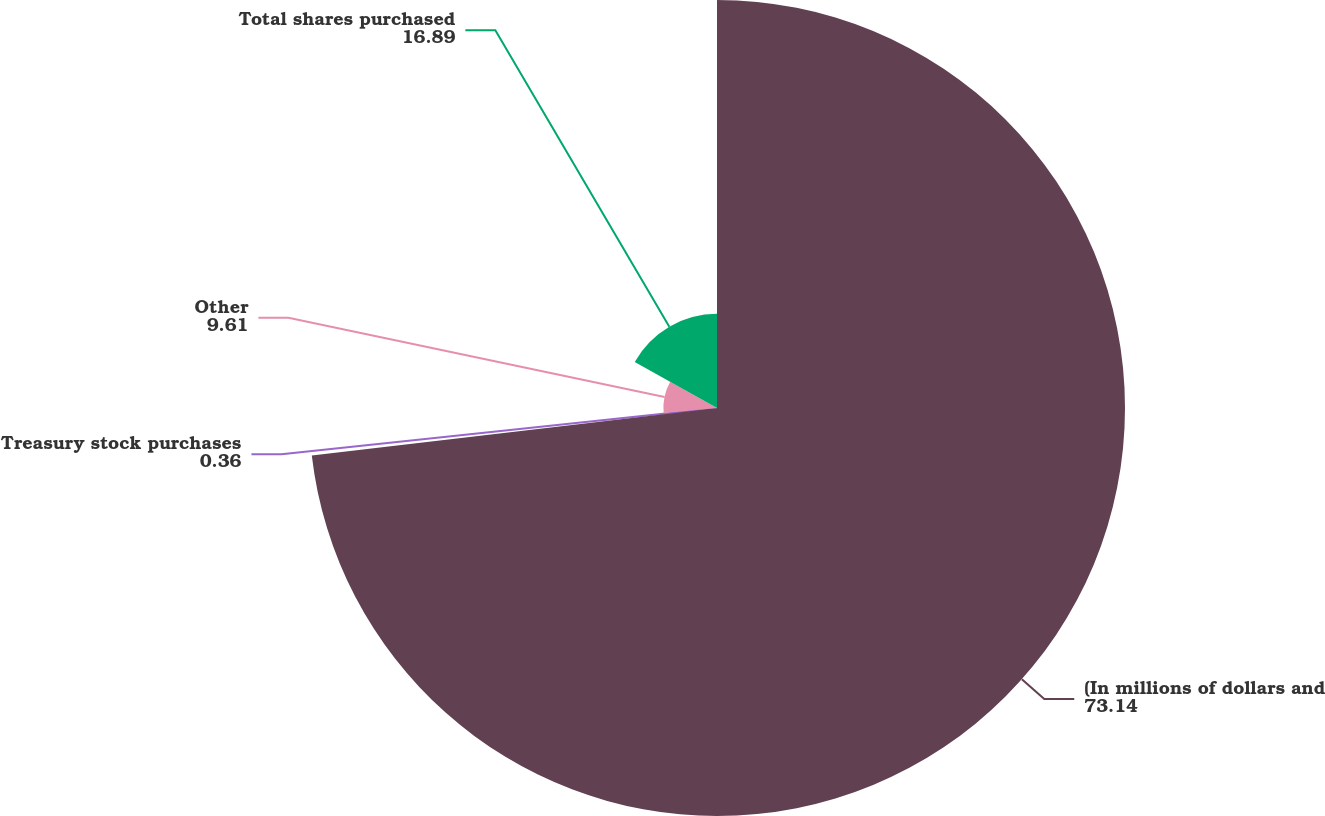<chart> <loc_0><loc_0><loc_500><loc_500><pie_chart><fcel>(In millions of dollars and<fcel>Treasury stock purchases<fcel>Other<fcel>Total shares purchased<nl><fcel>73.14%<fcel>0.36%<fcel>9.61%<fcel>16.89%<nl></chart> 